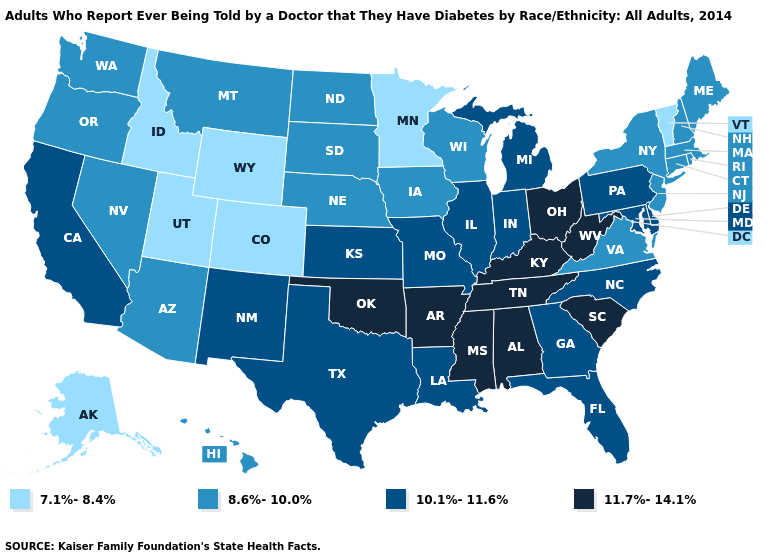Among the states that border Wyoming , which have the highest value?
Answer briefly. Montana, Nebraska, South Dakota. Does Nebraska have a lower value than Kansas?
Be succinct. Yes. Does Iowa have the lowest value in the MidWest?
Short answer required. No. Name the states that have a value in the range 10.1%-11.6%?
Keep it brief. California, Delaware, Florida, Georgia, Illinois, Indiana, Kansas, Louisiana, Maryland, Michigan, Missouri, New Mexico, North Carolina, Pennsylvania, Texas. How many symbols are there in the legend?
Give a very brief answer. 4. Among the states that border Alabama , does Florida have the highest value?
Give a very brief answer. No. Does Ohio have the lowest value in the USA?
Quick response, please. No. Name the states that have a value in the range 11.7%-14.1%?
Quick response, please. Alabama, Arkansas, Kentucky, Mississippi, Ohio, Oklahoma, South Carolina, Tennessee, West Virginia. Among the states that border Montana , which have the highest value?
Be succinct. North Dakota, South Dakota. What is the highest value in the South ?
Keep it brief. 11.7%-14.1%. Does the map have missing data?
Write a very short answer. No. How many symbols are there in the legend?
Answer briefly. 4. What is the value of Montana?
Write a very short answer. 8.6%-10.0%. Name the states that have a value in the range 8.6%-10.0%?
Answer briefly. Arizona, Connecticut, Hawaii, Iowa, Maine, Massachusetts, Montana, Nebraska, Nevada, New Hampshire, New Jersey, New York, North Dakota, Oregon, Rhode Island, South Dakota, Virginia, Washington, Wisconsin. 